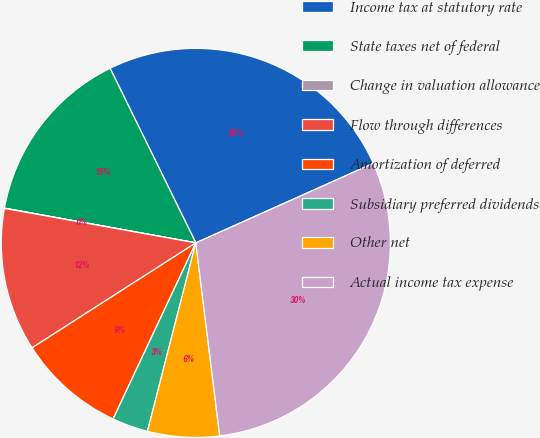<chart> <loc_0><loc_0><loc_500><loc_500><pie_chart><fcel>Income tax at statutory rate<fcel>State taxes net of federal<fcel>Change in valuation allowance<fcel>Flow through differences<fcel>Amortization of deferred<fcel>Subsidiary preferred dividends<fcel>Other net<fcel>Actual income tax expense<nl><fcel>25.56%<fcel>14.88%<fcel>0.02%<fcel>11.91%<fcel>8.94%<fcel>2.99%<fcel>5.96%<fcel>29.75%<nl></chart> 